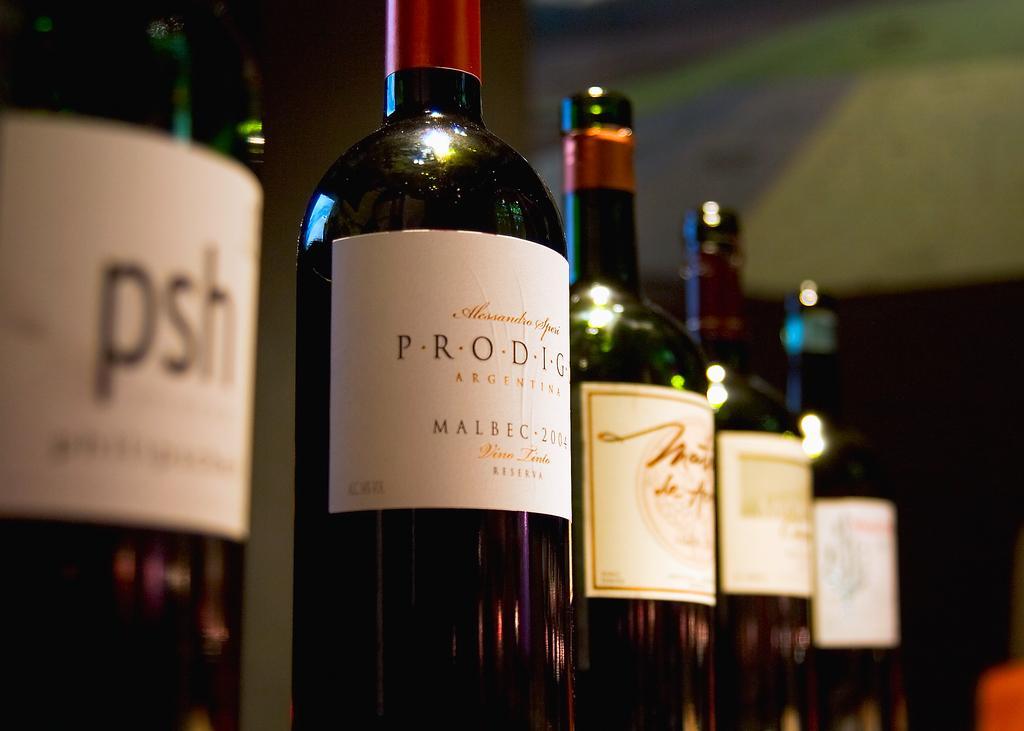Please provide a concise description of this image. In this picture there are bottles in series in the center of the image. 